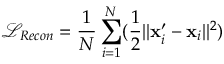<formula> <loc_0><loc_0><loc_500><loc_500>\mathcal { L } _ { R e c o n } = \frac { 1 } { N } \sum _ { i = 1 } ^ { N } ( \frac { 1 } { 2 } | | x _ { i } ^ { \prime } - x _ { i } | | ^ { 2 } )</formula> 